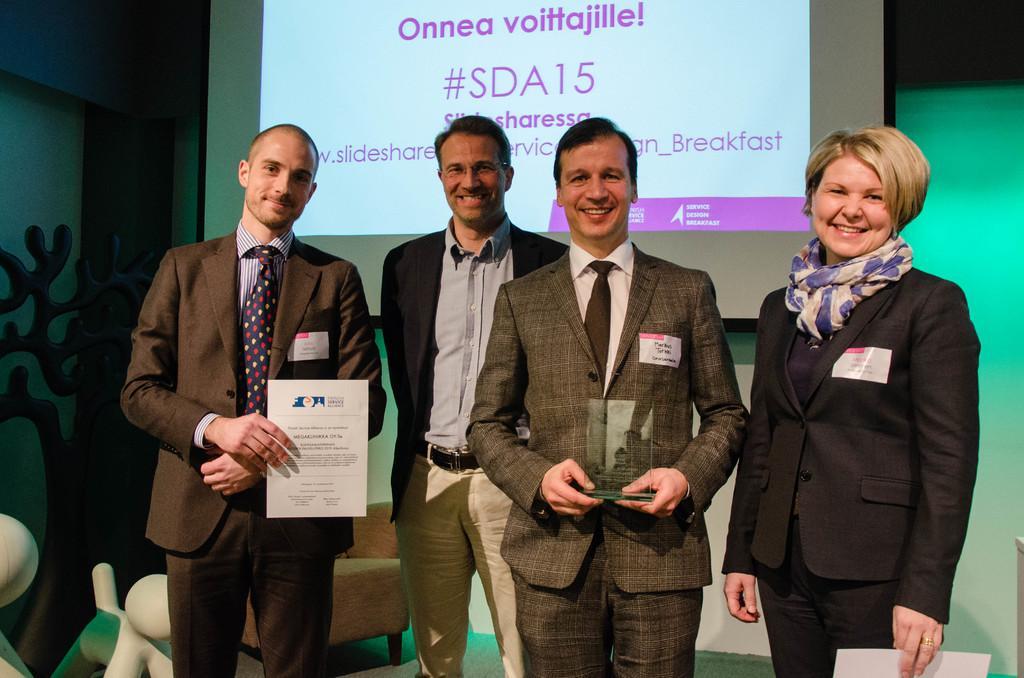In one or two sentences, can you explain what this image depicts? In this picture in the front there are persons standing and smiling. In the background there is a screen with some text written on it and there is a sofa and there are objects which are white in colour and black in colour. 